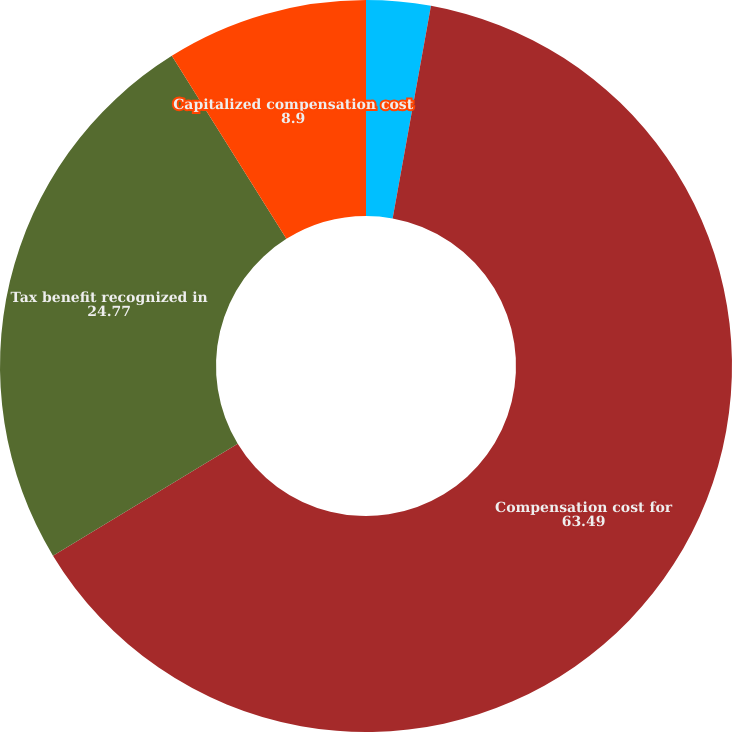Convert chart. <chart><loc_0><loc_0><loc_500><loc_500><pie_chart><fcel>(Thousands of Dollars)<fcel>Compensation cost for<fcel>Tax benefit recognized in<fcel>Capitalized compensation cost<nl><fcel>2.84%<fcel>63.49%<fcel>24.77%<fcel>8.9%<nl></chart> 